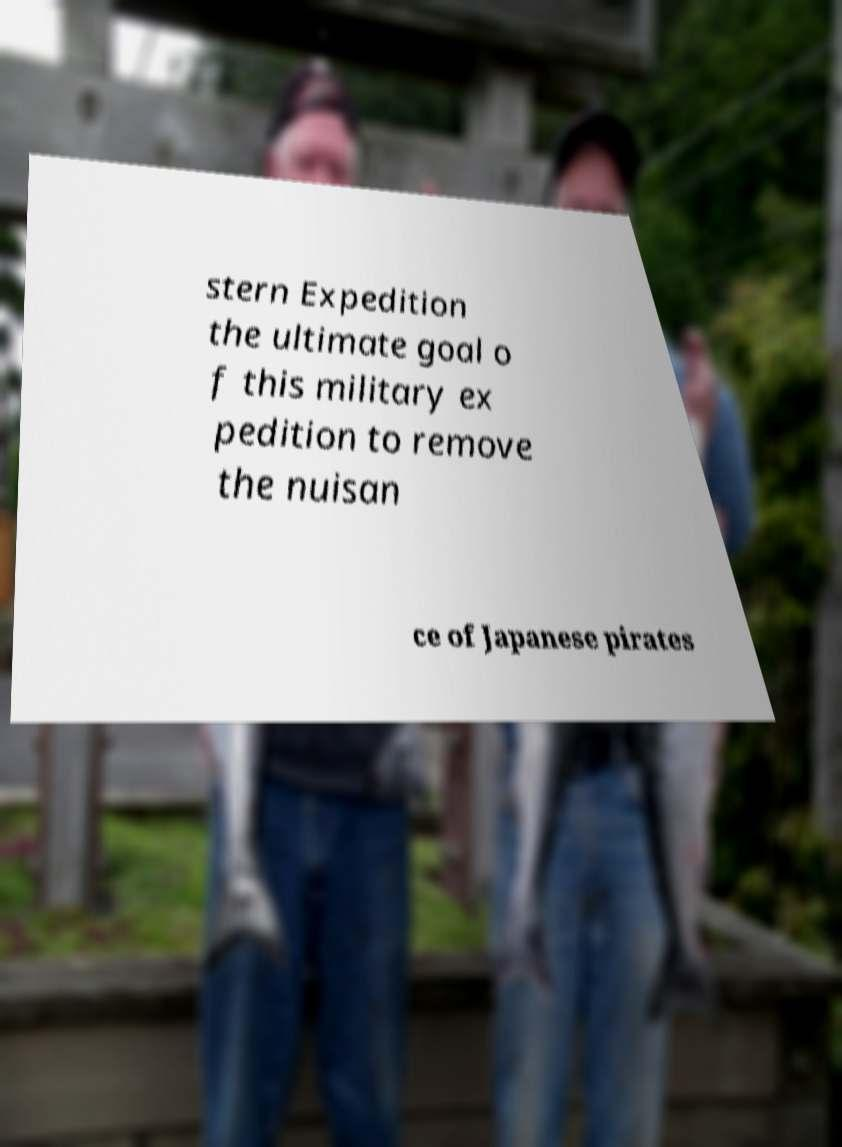Please identify and transcribe the text found in this image. stern Expedition the ultimate goal o f this military ex pedition to remove the nuisan ce of Japanese pirates 